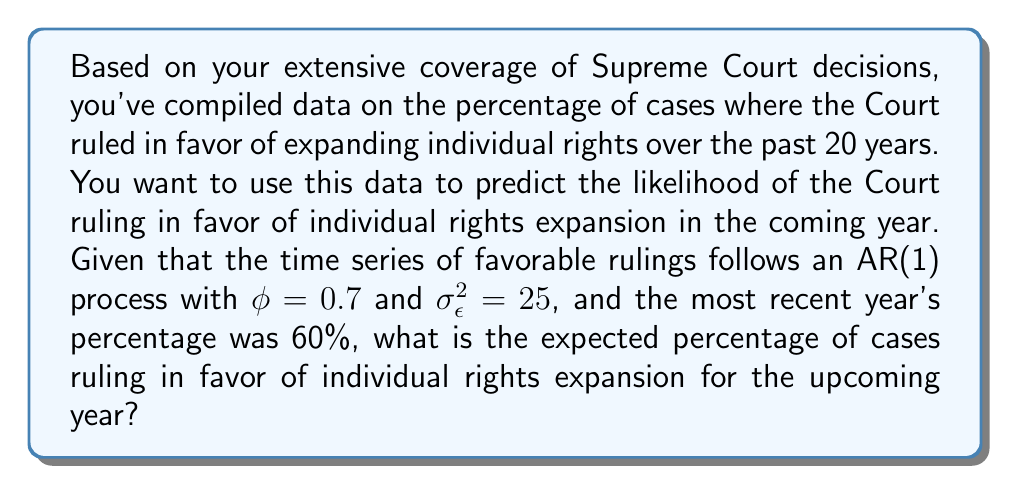Help me with this question. To solve this problem, we need to understand the AR(1) process and how to use it for forecasting. An AR(1) process is defined as:

$$Y_t = c + \phi Y_{t-1} + \epsilon_t$$

Where:
- $Y_t$ is the value at time t
- $c$ is a constant (intercept)
- $\phi$ is the autoregressive coefficient
- $Y_{t-1}$ is the value at time t-1
- $\epsilon_t$ is white noise with variance $\sigma_\epsilon^2$

For forecasting one step ahead, we use the expected value:

$$E[Y_{t+1}|Y_t] = c + \phi Y_t$$

In this case, we don't have a specified constant $c$, so we can assume it's 0 for simplicity. We're given:

- $\phi = 0.7$
- $Y_t = 60$ (the most recent year's percentage)

Step 1: Apply the AR(1) forecasting formula
$$E[Y_{t+1}|Y_t] = 0 + 0.7 * 60$$

Step 2: Calculate the expected value
$$E[Y_{t+1}|Y_t] = 42$$

Therefore, the expected percentage of cases ruling in favor of individual rights expansion for the upcoming year is 42%.

Note: The variance $\sigma_\epsilon^2 = 25$ is not used in calculating the point forecast, but it would be useful for constructing prediction intervals.
Answer: 42% 